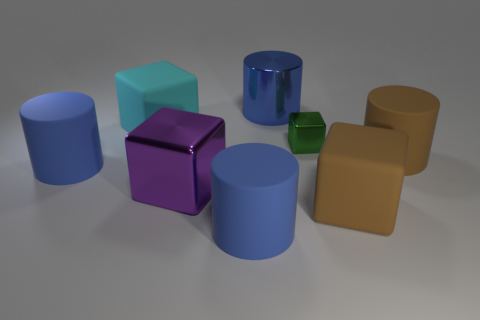What shades of color do you see in the objects presented in the image? The image showcases a variety of color shades. There's a light teal, purple, and tiny green cube, along with blue and brown cylinders. The blues range from a soft, powdery hue on the larger cylinders to a brighter, more vibrant blue on the smaller one. The brown cylinder has a muted, earthy tone. 